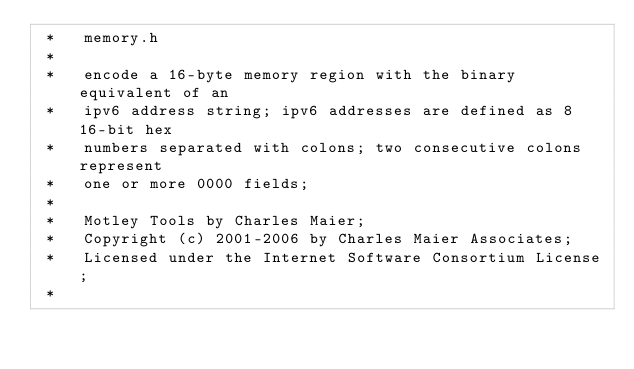<code> <loc_0><loc_0><loc_500><loc_500><_C_> *   memory.h
 *
 *   encode a 16-byte memory region with the binary equivalent of an
 *   ipv6 address string; ipv6 addresses are defined as 8 16-bit hex
 *   numbers separated with colons; two consecutive colons represent
 *   one or more 0000 fields;
 *
 *   Motley Tools by Charles Maier;
 *   Copyright (c) 2001-2006 by Charles Maier Associates;
 *   Licensed under the Internet Software Consortium License;
 *</code> 